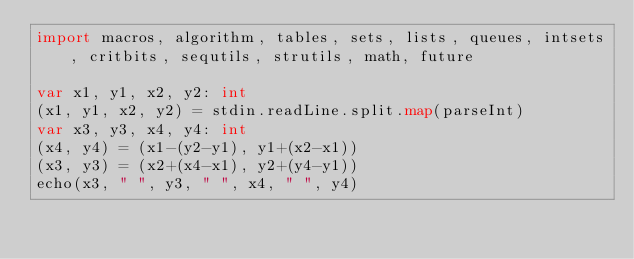Convert code to text. <code><loc_0><loc_0><loc_500><loc_500><_Nim_>import macros, algorithm, tables, sets, lists, queues, intsets, critbits, sequtils, strutils, math, future

var x1, y1, x2, y2: int
(x1, y1, x2, y2) = stdin.readLine.split.map(parseInt)
var x3, y3, x4, y4: int
(x4, y4) = (x1-(y2-y1), y1+(x2-x1))
(x3, y3) = (x2+(x4-x1), y2+(y4-y1))
echo(x3, " ", y3, " ", x4, " ", y4)</code> 